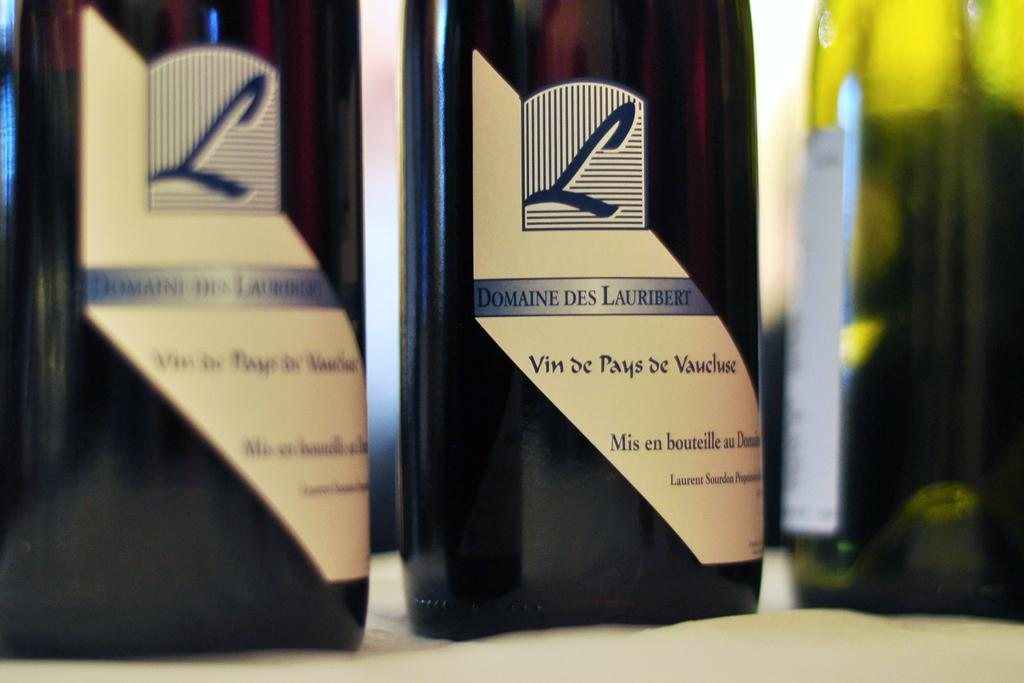<image>
Summarize the visual content of the image. a wine bottle that says 'l domaine des lauribert' on it 